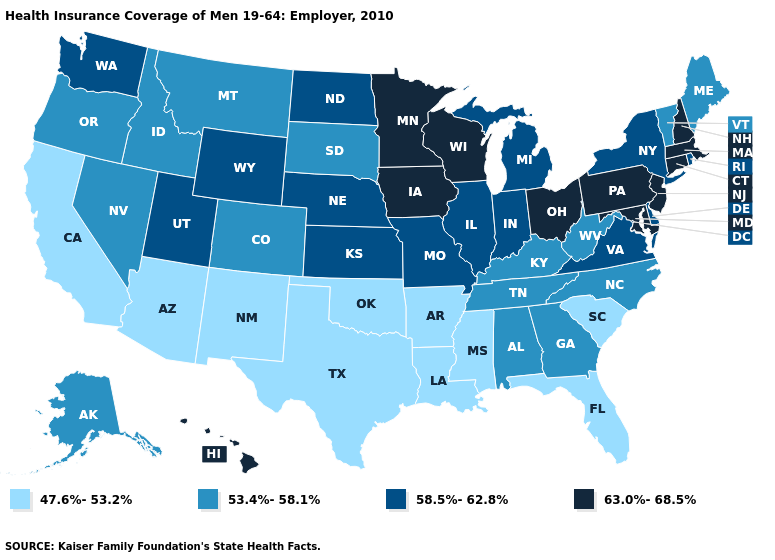What is the value of Georgia?
Be succinct. 53.4%-58.1%. Does Arkansas have the lowest value in the South?
Answer briefly. Yes. Which states have the highest value in the USA?
Concise answer only. Connecticut, Hawaii, Iowa, Maryland, Massachusetts, Minnesota, New Hampshire, New Jersey, Ohio, Pennsylvania, Wisconsin. Name the states that have a value in the range 53.4%-58.1%?
Be succinct. Alabama, Alaska, Colorado, Georgia, Idaho, Kentucky, Maine, Montana, Nevada, North Carolina, Oregon, South Dakota, Tennessee, Vermont, West Virginia. What is the highest value in states that border Utah?
Keep it brief. 58.5%-62.8%. Does the map have missing data?
Write a very short answer. No. Name the states that have a value in the range 63.0%-68.5%?
Quick response, please. Connecticut, Hawaii, Iowa, Maryland, Massachusetts, Minnesota, New Hampshire, New Jersey, Ohio, Pennsylvania, Wisconsin. Does Wyoming have a higher value than Pennsylvania?
Keep it brief. No. Which states have the lowest value in the USA?
Keep it brief. Arizona, Arkansas, California, Florida, Louisiana, Mississippi, New Mexico, Oklahoma, South Carolina, Texas. What is the value of Idaho?
Short answer required. 53.4%-58.1%. Name the states that have a value in the range 63.0%-68.5%?
Be succinct. Connecticut, Hawaii, Iowa, Maryland, Massachusetts, Minnesota, New Hampshire, New Jersey, Ohio, Pennsylvania, Wisconsin. Name the states that have a value in the range 63.0%-68.5%?
Be succinct. Connecticut, Hawaii, Iowa, Maryland, Massachusetts, Minnesota, New Hampshire, New Jersey, Ohio, Pennsylvania, Wisconsin. Among the states that border Arizona , which have the highest value?
Quick response, please. Utah. What is the value of New Hampshire?
Give a very brief answer. 63.0%-68.5%. Does the first symbol in the legend represent the smallest category?
Keep it brief. Yes. 